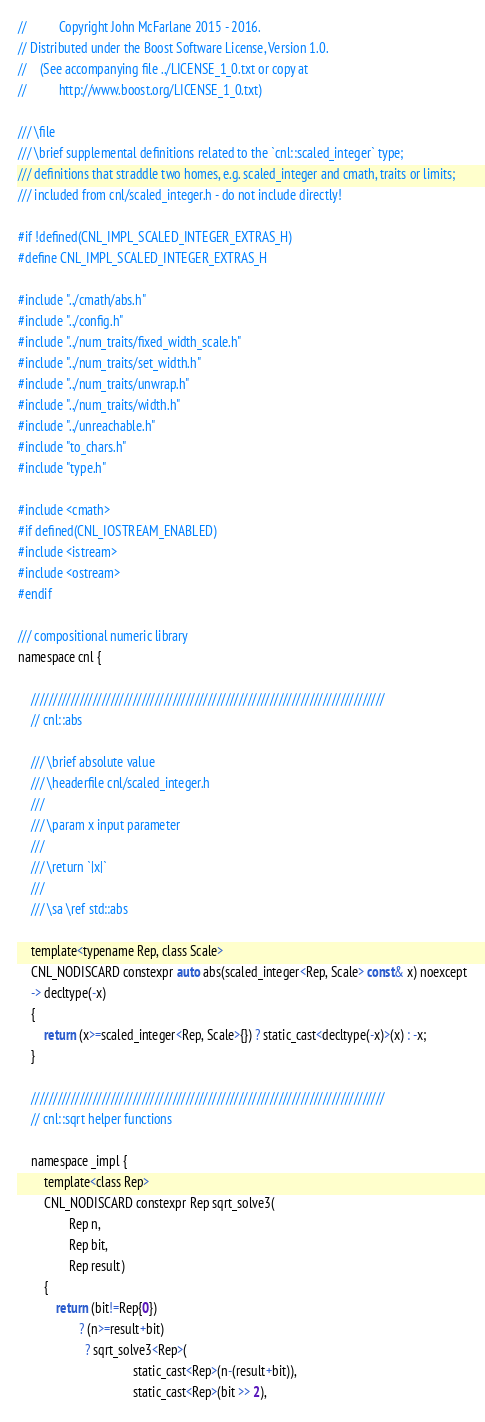Convert code to text. <code><loc_0><loc_0><loc_500><loc_500><_C_>
//          Copyright John McFarlane 2015 - 2016.
// Distributed under the Boost Software License, Version 1.0.
//    (See accompanying file ../LICENSE_1_0.txt or copy at
//          http://www.boost.org/LICENSE_1_0.txt)

/// \file
/// \brief supplemental definitions related to the `cnl::scaled_integer` type;
/// definitions that straddle two homes, e.g. scaled_integer and cmath, traits or limits;
/// included from cnl/scaled_integer.h - do not include directly!

#if !defined(CNL_IMPL_SCALED_INTEGER_EXTRAS_H)
#define CNL_IMPL_SCALED_INTEGER_EXTRAS_H

#include "../cmath/abs.h"
#include "../config.h"
#include "../num_traits/fixed_width_scale.h"
#include "../num_traits/set_width.h"
#include "../num_traits/unwrap.h"
#include "../num_traits/width.h"
#include "../unreachable.h"
#include "to_chars.h"
#include "type.h"

#include <cmath>
#if defined(CNL_IOSTREAM_ENABLED)
#include <istream>
#include <ostream>
#endif

/// compositional numeric library
namespace cnl {

    ////////////////////////////////////////////////////////////////////////////////
    // cnl::abs

    /// \brief absolute value
    /// \headerfile cnl/scaled_integer.h
    ///
    /// \param x input parameter
    ///
    /// \return `|x|`
    ///
    /// \sa \ref std::abs

    template<typename Rep, class Scale>
    CNL_NODISCARD constexpr auto abs(scaled_integer<Rep, Scale> const& x) noexcept
    -> decltype(-x)
    {
        return (x>=scaled_integer<Rep, Scale>{}) ? static_cast<decltype(-x)>(x) : -x;
    }

    ////////////////////////////////////////////////////////////////////////////////
    // cnl::sqrt helper functions

    namespace _impl {
        template<class Rep>
        CNL_NODISCARD constexpr Rep sqrt_solve3(
                Rep n,
                Rep bit,
                Rep result)
        {
            return (bit!=Rep{0})
                   ? (n>=result+bit)
                     ? sqrt_solve3<Rep>(
                                    static_cast<Rep>(n-(result+bit)),
                                    static_cast<Rep>(bit >> 2),</code> 